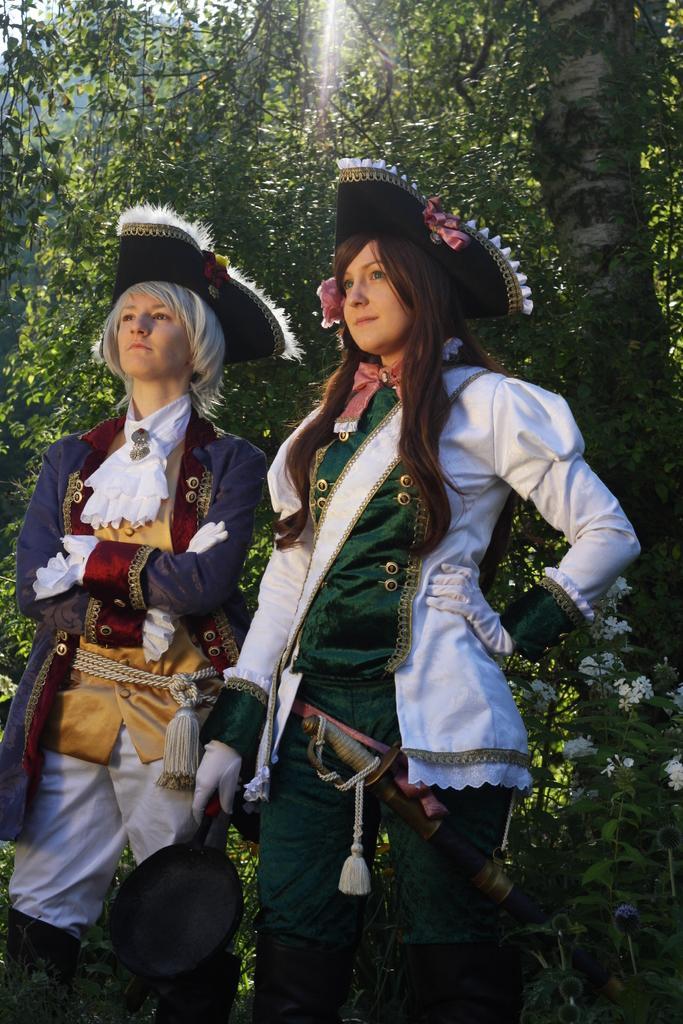Can you describe this image briefly? In this image, we can see some trees and plants. There is person in the middle of the image wearing clothes and holding pan with her hand. There is an another person on the left side of the image standing and wearing clothes. 